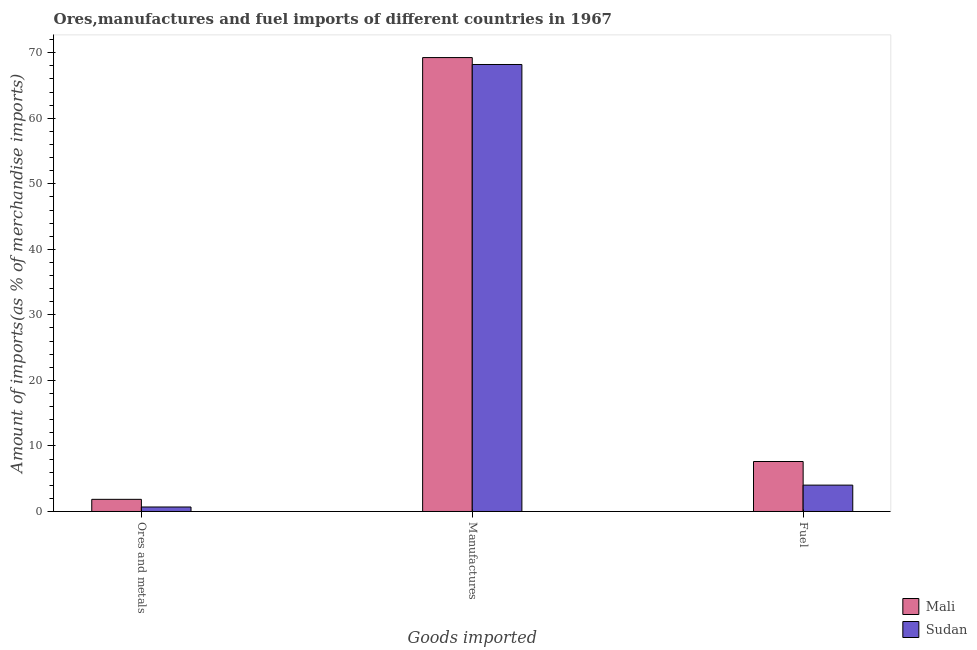How many different coloured bars are there?
Your answer should be compact. 2. How many bars are there on the 2nd tick from the left?
Provide a succinct answer. 2. How many bars are there on the 1st tick from the right?
Your answer should be very brief. 2. What is the label of the 3rd group of bars from the left?
Make the answer very short. Fuel. What is the percentage of fuel imports in Mali?
Make the answer very short. 7.63. Across all countries, what is the maximum percentage of ores and metals imports?
Your answer should be compact. 1.85. Across all countries, what is the minimum percentage of manufactures imports?
Make the answer very short. 68.21. In which country was the percentage of ores and metals imports maximum?
Your answer should be very brief. Mali. In which country was the percentage of ores and metals imports minimum?
Your answer should be very brief. Sudan. What is the total percentage of manufactures imports in the graph?
Ensure brevity in your answer.  137.48. What is the difference between the percentage of ores and metals imports in Mali and that in Sudan?
Provide a succinct answer. 1.17. What is the difference between the percentage of manufactures imports in Mali and the percentage of ores and metals imports in Sudan?
Keep it short and to the point. 68.58. What is the average percentage of ores and metals imports per country?
Make the answer very short. 1.27. What is the difference between the percentage of manufactures imports and percentage of fuel imports in Mali?
Ensure brevity in your answer.  61.64. In how many countries, is the percentage of manufactures imports greater than 64 %?
Offer a very short reply. 2. What is the ratio of the percentage of ores and metals imports in Sudan to that in Mali?
Your response must be concise. 0.37. What is the difference between the highest and the second highest percentage of manufactures imports?
Your answer should be very brief. 1.06. What is the difference between the highest and the lowest percentage of manufactures imports?
Offer a terse response. 1.06. What does the 1st bar from the left in Manufactures represents?
Your answer should be compact. Mali. What does the 2nd bar from the right in Ores and metals represents?
Provide a succinct answer. Mali. How many bars are there?
Offer a terse response. 6. Are the values on the major ticks of Y-axis written in scientific E-notation?
Give a very brief answer. No. Does the graph contain any zero values?
Ensure brevity in your answer.  No. Does the graph contain grids?
Offer a terse response. No. Where does the legend appear in the graph?
Provide a short and direct response. Bottom right. What is the title of the graph?
Make the answer very short. Ores,manufactures and fuel imports of different countries in 1967. What is the label or title of the X-axis?
Ensure brevity in your answer.  Goods imported. What is the label or title of the Y-axis?
Ensure brevity in your answer.  Amount of imports(as % of merchandise imports). What is the Amount of imports(as % of merchandise imports) of Mali in Ores and metals?
Offer a terse response. 1.85. What is the Amount of imports(as % of merchandise imports) in Sudan in Ores and metals?
Your response must be concise. 0.69. What is the Amount of imports(as % of merchandise imports) of Mali in Manufactures?
Provide a succinct answer. 69.27. What is the Amount of imports(as % of merchandise imports) in Sudan in Manufactures?
Provide a short and direct response. 68.21. What is the Amount of imports(as % of merchandise imports) of Mali in Fuel?
Your answer should be compact. 7.63. What is the Amount of imports(as % of merchandise imports) in Sudan in Fuel?
Make the answer very short. 4.02. Across all Goods imported, what is the maximum Amount of imports(as % of merchandise imports) of Mali?
Your response must be concise. 69.27. Across all Goods imported, what is the maximum Amount of imports(as % of merchandise imports) of Sudan?
Offer a terse response. 68.21. Across all Goods imported, what is the minimum Amount of imports(as % of merchandise imports) in Mali?
Keep it short and to the point. 1.85. Across all Goods imported, what is the minimum Amount of imports(as % of merchandise imports) in Sudan?
Offer a terse response. 0.69. What is the total Amount of imports(as % of merchandise imports) of Mali in the graph?
Keep it short and to the point. 78.75. What is the total Amount of imports(as % of merchandise imports) of Sudan in the graph?
Offer a terse response. 72.92. What is the difference between the Amount of imports(as % of merchandise imports) in Mali in Ores and metals and that in Manufactures?
Provide a succinct answer. -67.41. What is the difference between the Amount of imports(as % of merchandise imports) in Sudan in Ores and metals and that in Manufactures?
Provide a succinct answer. -67.52. What is the difference between the Amount of imports(as % of merchandise imports) in Mali in Ores and metals and that in Fuel?
Make the answer very short. -5.77. What is the difference between the Amount of imports(as % of merchandise imports) of Sudan in Ores and metals and that in Fuel?
Give a very brief answer. -3.34. What is the difference between the Amount of imports(as % of merchandise imports) in Mali in Manufactures and that in Fuel?
Give a very brief answer. 61.64. What is the difference between the Amount of imports(as % of merchandise imports) of Sudan in Manufactures and that in Fuel?
Give a very brief answer. 64.19. What is the difference between the Amount of imports(as % of merchandise imports) in Mali in Ores and metals and the Amount of imports(as % of merchandise imports) in Sudan in Manufactures?
Your answer should be compact. -66.36. What is the difference between the Amount of imports(as % of merchandise imports) of Mali in Ores and metals and the Amount of imports(as % of merchandise imports) of Sudan in Fuel?
Keep it short and to the point. -2.17. What is the difference between the Amount of imports(as % of merchandise imports) in Mali in Manufactures and the Amount of imports(as % of merchandise imports) in Sudan in Fuel?
Offer a very short reply. 65.24. What is the average Amount of imports(as % of merchandise imports) in Mali per Goods imported?
Give a very brief answer. 26.25. What is the average Amount of imports(as % of merchandise imports) in Sudan per Goods imported?
Give a very brief answer. 24.31. What is the difference between the Amount of imports(as % of merchandise imports) in Mali and Amount of imports(as % of merchandise imports) in Sudan in Ores and metals?
Your answer should be very brief. 1.17. What is the difference between the Amount of imports(as % of merchandise imports) of Mali and Amount of imports(as % of merchandise imports) of Sudan in Manufactures?
Give a very brief answer. 1.06. What is the difference between the Amount of imports(as % of merchandise imports) of Mali and Amount of imports(as % of merchandise imports) of Sudan in Fuel?
Give a very brief answer. 3.6. What is the ratio of the Amount of imports(as % of merchandise imports) of Mali in Ores and metals to that in Manufactures?
Provide a short and direct response. 0.03. What is the ratio of the Amount of imports(as % of merchandise imports) of Sudan in Ores and metals to that in Manufactures?
Your response must be concise. 0.01. What is the ratio of the Amount of imports(as % of merchandise imports) in Mali in Ores and metals to that in Fuel?
Provide a short and direct response. 0.24. What is the ratio of the Amount of imports(as % of merchandise imports) in Sudan in Ores and metals to that in Fuel?
Provide a short and direct response. 0.17. What is the ratio of the Amount of imports(as % of merchandise imports) of Mali in Manufactures to that in Fuel?
Give a very brief answer. 9.08. What is the ratio of the Amount of imports(as % of merchandise imports) of Sudan in Manufactures to that in Fuel?
Give a very brief answer. 16.95. What is the difference between the highest and the second highest Amount of imports(as % of merchandise imports) in Mali?
Your response must be concise. 61.64. What is the difference between the highest and the second highest Amount of imports(as % of merchandise imports) of Sudan?
Give a very brief answer. 64.19. What is the difference between the highest and the lowest Amount of imports(as % of merchandise imports) of Mali?
Offer a very short reply. 67.41. What is the difference between the highest and the lowest Amount of imports(as % of merchandise imports) in Sudan?
Offer a terse response. 67.52. 